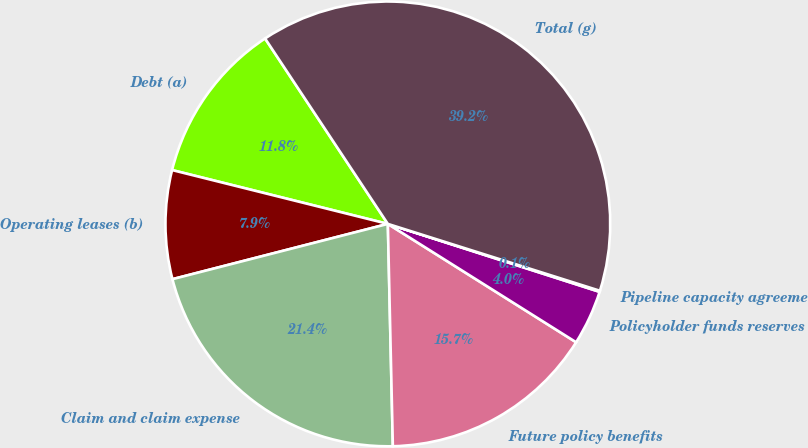Convert chart to OTSL. <chart><loc_0><loc_0><loc_500><loc_500><pie_chart><fcel>Debt (a)<fcel>Operating leases (b)<fcel>Claim and claim expense<fcel>Future policy benefits<fcel>Policyholder funds reserves<fcel>Pipeline capacity agreements<fcel>Total (g)<nl><fcel>11.8%<fcel>7.89%<fcel>21.36%<fcel>15.71%<fcel>3.99%<fcel>0.08%<fcel>39.17%<nl></chart> 